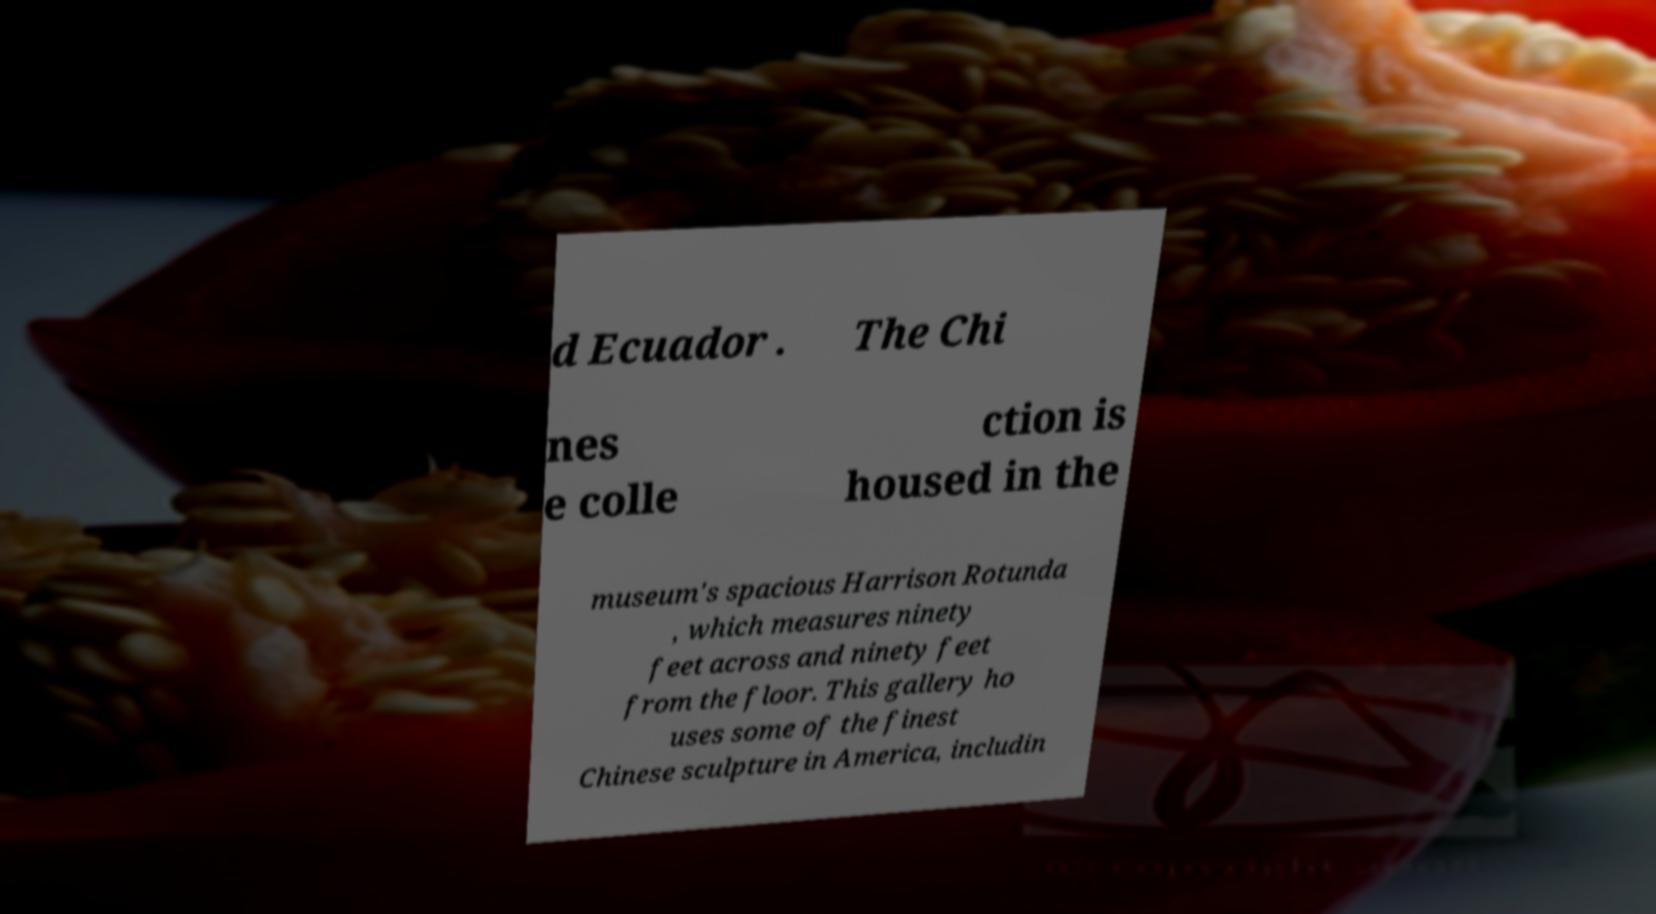Can you accurately transcribe the text from the provided image for me? d Ecuador . The Chi nes e colle ction is housed in the museum's spacious Harrison Rotunda , which measures ninety feet across and ninety feet from the floor. This gallery ho uses some of the finest Chinese sculpture in America, includin 